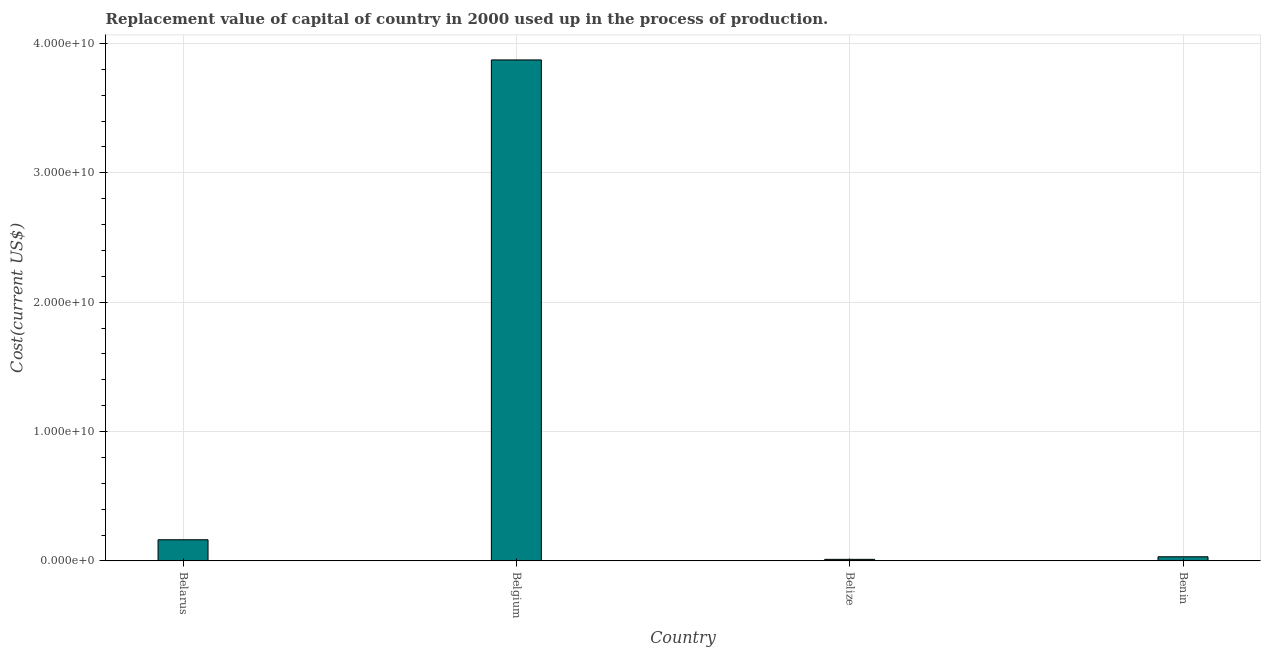Does the graph contain any zero values?
Keep it short and to the point. No. What is the title of the graph?
Make the answer very short. Replacement value of capital of country in 2000 used up in the process of production. What is the label or title of the X-axis?
Offer a very short reply. Country. What is the label or title of the Y-axis?
Provide a succinct answer. Cost(current US$). What is the consumption of fixed capital in Belize?
Provide a succinct answer. 1.20e+08. Across all countries, what is the maximum consumption of fixed capital?
Your answer should be very brief. 3.87e+1. Across all countries, what is the minimum consumption of fixed capital?
Ensure brevity in your answer.  1.20e+08. In which country was the consumption of fixed capital maximum?
Ensure brevity in your answer.  Belgium. In which country was the consumption of fixed capital minimum?
Make the answer very short. Belize. What is the sum of the consumption of fixed capital?
Your answer should be compact. 4.08e+1. What is the difference between the consumption of fixed capital in Belarus and Belize?
Offer a terse response. 1.51e+09. What is the average consumption of fixed capital per country?
Your response must be concise. 1.02e+1. What is the median consumption of fixed capital?
Provide a short and direct response. 9.77e+08. What is the ratio of the consumption of fixed capital in Belarus to that in Benin?
Give a very brief answer. 5.12. Is the consumption of fixed capital in Belgium less than that in Benin?
Provide a succinct answer. No. Is the difference between the consumption of fixed capital in Belize and Benin greater than the difference between any two countries?
Your answer should be compact. No. What is the difference between the highest and the second highest consumption of fixed capital?
Ensure brevity in your answer.  3.71e+1. What is the difference between the highest and the lowest consumption of fixed capital?
Ensure brevity in your answer.  3.86e+1. How many bars are there?
Provide a short and direct response. 4. How many countries are there in the graph?
Provide a succinct answer. 4. What is the Cost(current US$) of Belarus?
Give a very brief answer. 1.63e+09. What is the Cost(current US$) of Belgium?
Ensure brevity in your answer.  3.87e+1. What is the Cost(current US$) in Belize?
Offer a very short reply. 1.20e+08. What is the Cost(current US$) in Benin?
Provide a short and direct response. 3.19e+08. What is the difference between the Cost(current US$) in Belarus and Belgium?
Offer a terse response. -3.71e+1. What is the difference between the Cost(current US$) in Belarus and Belize?
Your answer should be compact. 1.51e+09. What is the difference between the Cost(current US$) in Belarus and Benin?
Your response must be concise. 1.31e+09. What is the difference between the Cost(current US$) in Belgium and Belize?
Your response must be concise. 3.86e+1. What is the difference between the Cost(current US$) in Belgium and Benin?
Your answer should be compact. 3.84e+1. What is the difference between the Cost(current US$) in Belize and Benin?
Your answer should be compact. -1.99e+08. What is the ratio of the Cost(current US$) in Belarus to that in Belgium?
Make the answer very short. 0.04. What is the ratio of the Cost(current US$) in Belarus to that in Belize?
Your answer should be compact. 13.62. What is the ratio of the Cost(current US$) in Belarus to that in Benin?
Offer a terse response. 5.12. What is the ratio of the Cost(current US$) in Belgium to that in Belize?
Provide a short and direct response. 322.9. What is the ratio of the Cost(current US$) in Belgium to that in Benin?
Give a very brief answer. 121.24. What is the ratio of the Cost(current US$) in Belize to that in Benin?
Provide a short and direct response. 0.38. 